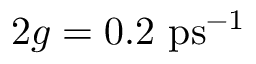Convert formula to latex. <formula><loc_0><loc_0><loc_500><loc_500>2 g = 0 . 2 \ p s ^ { - 1 }</formula> 